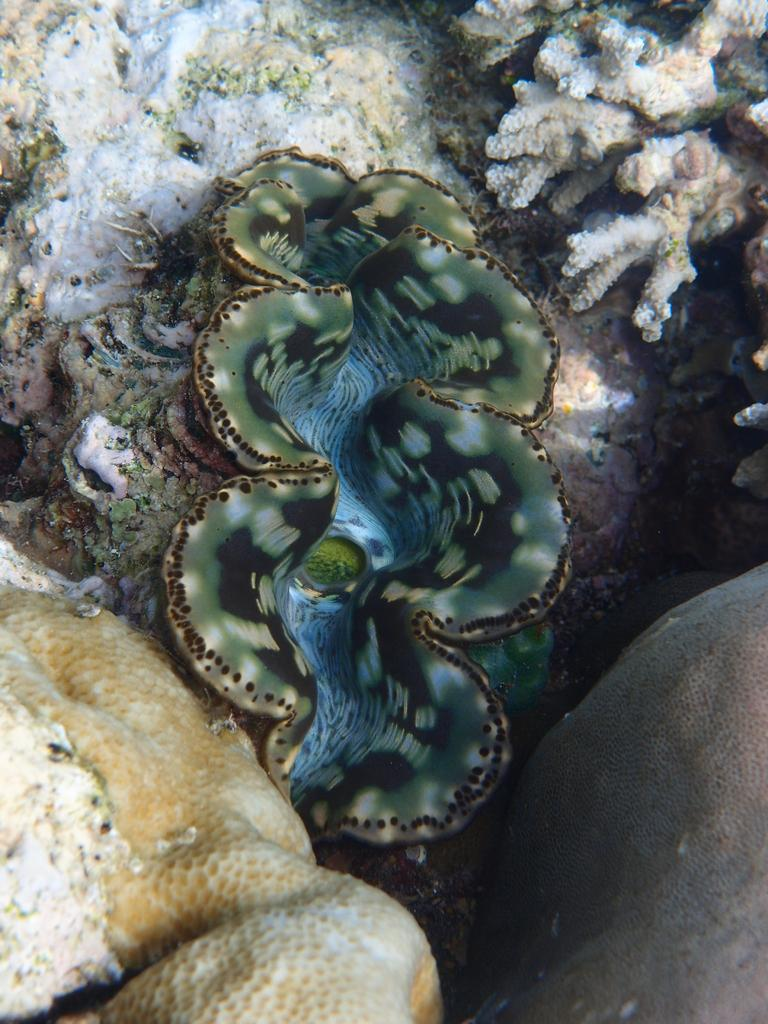What type of marine animal is in the image? There is a jellyfish in the image. What other marine life can be seen in the image? There are sea plants in the image. Where are the jellyfish and sea plants located? The jellyfish and sea plants are in water. What type of thing is causing the jellyfish to feel discomfort in the image? There is no indication in the image that the jellyfish is experiencing discomfort or that any "thing" is causing it. 